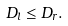<formula> <loc_0><loc_0><loc_500><loc_500>D _ { l } \leq D _ { r } .</formula> 